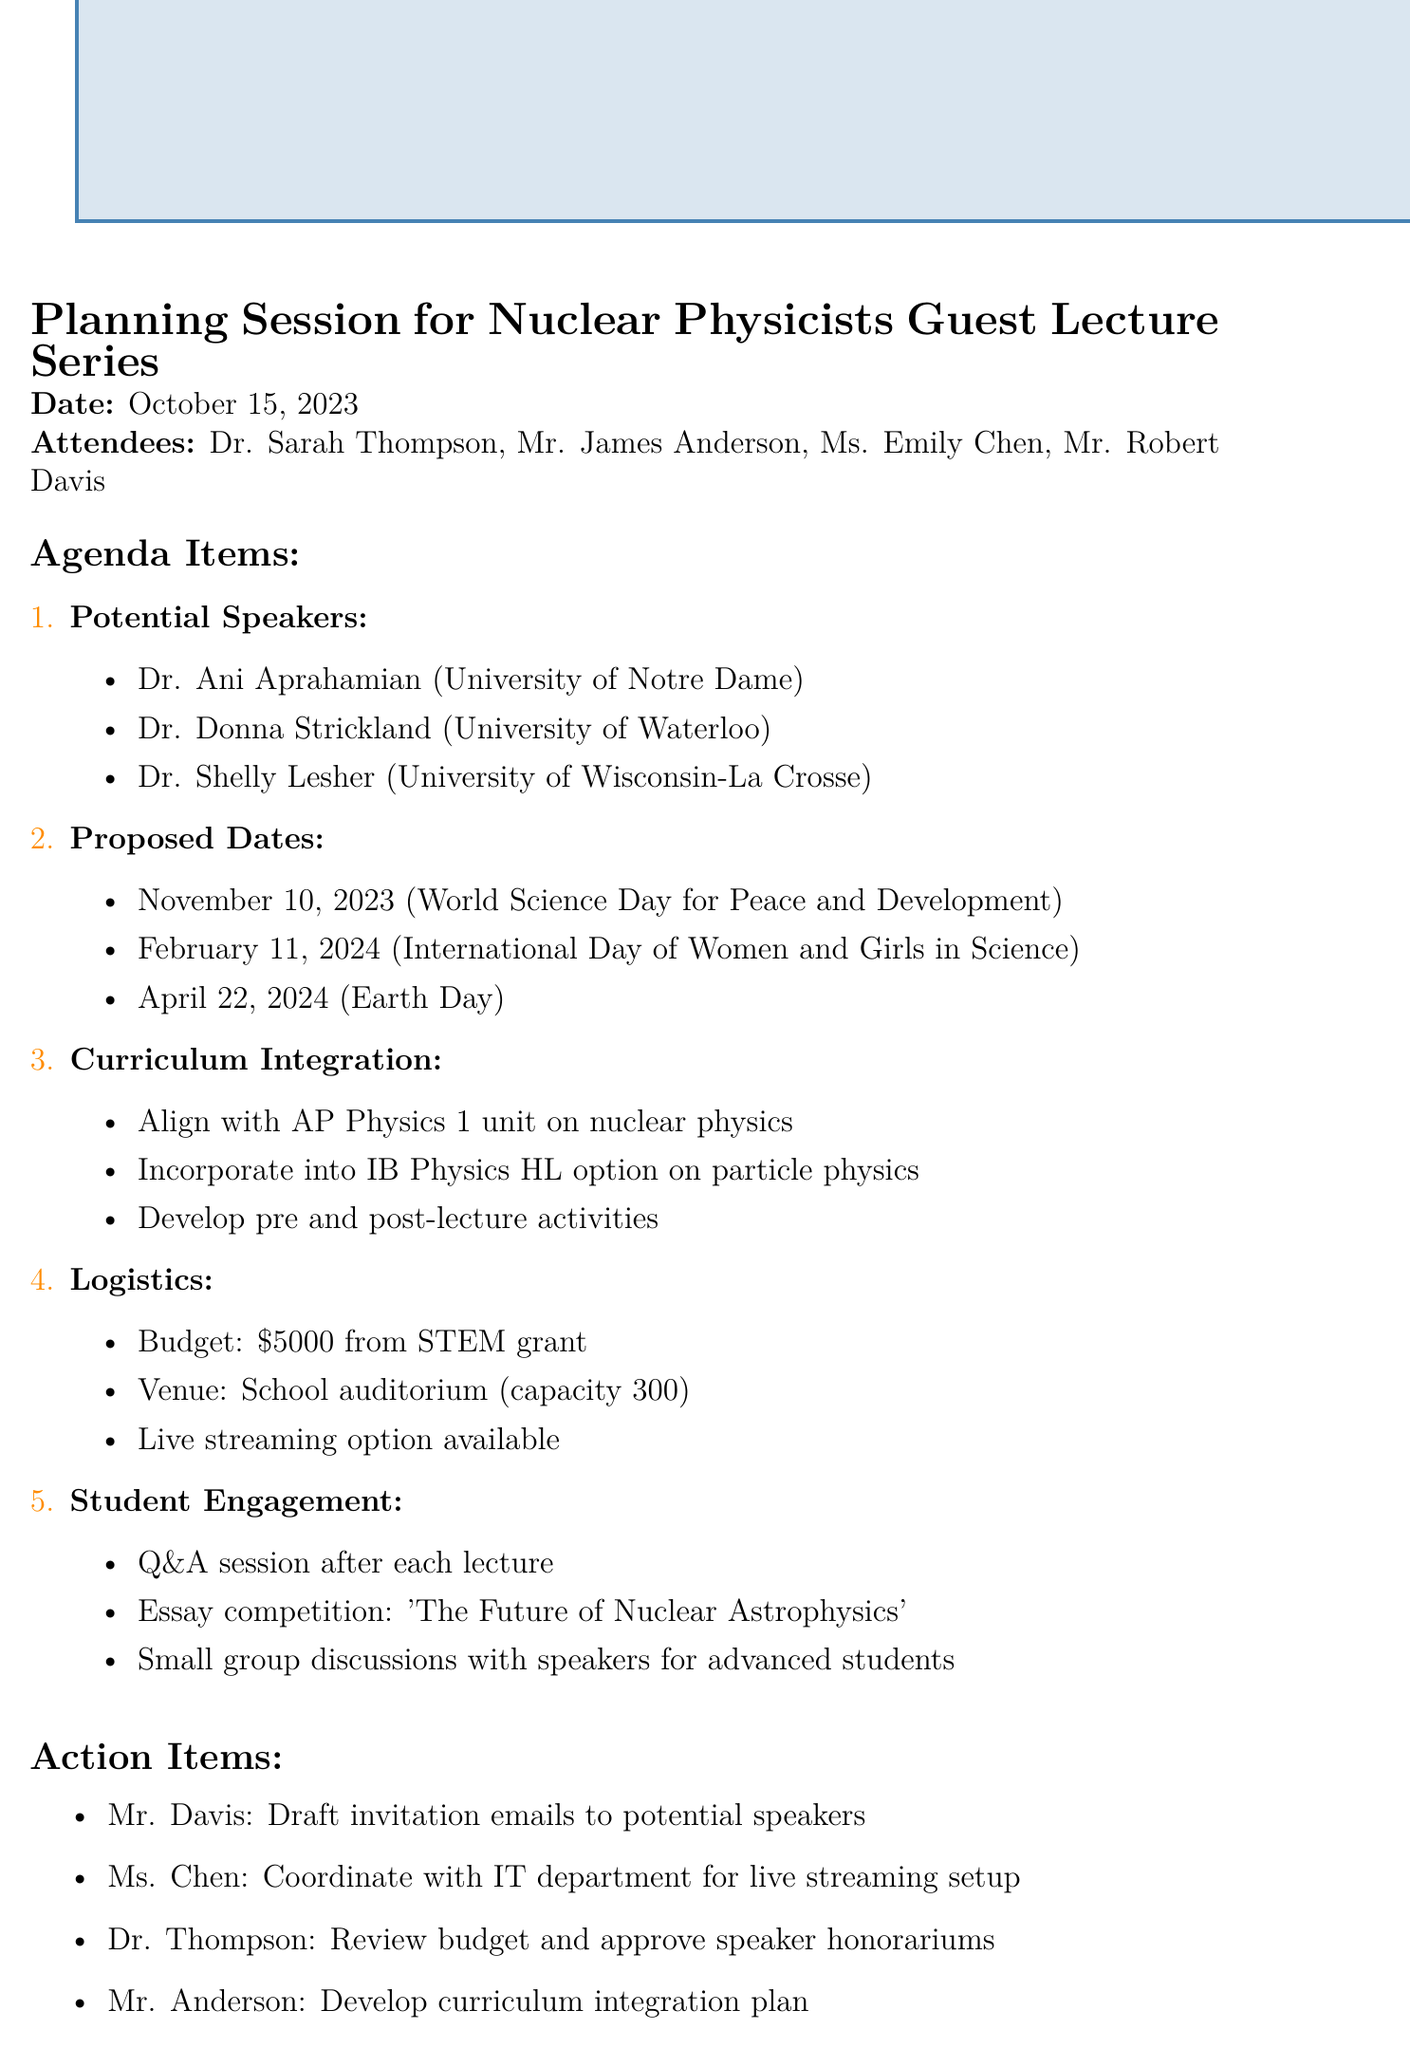What is the meeting date? The meeting date is explicitly stated in the document as October 15, 2023.
Answer: October 15, 2023 Who is one of the potential speakers? The document lists potential speakers, including Dr. Ani Aprahamian from the University of Notre Dame.
Answer: Dr. Ani Aprahamian What is the budget allocation for the event? The budget allocation is mentioned in the logistics section of the document as $5000 from the STEM grant.
Answer: $5000 What is one proposed date for the guest lecture series? The document proposes several dates, one being November 10, 2023, coinciding with World Science Day.
Answer: November 10, 2023 Which curriculum will be integrated with the guest lecture? The document specifies that the guest lecture series will align with the AP Physics 1 unit on nuclear physics.
Answer: AP Physics 1 How many attendees were present at the meeting? The document lists four attendees, indicating the number present at the meeting.
Answer: Four What activity will follow each lecture? The document states that a Q&A session will follow each lecture.
Answer: Q&A session What is an action item assigned to Mr. Davis? The action items section assigns Mr. Davis to draft invitation emails to potential speakers.
Answer: Draft invitation emails 